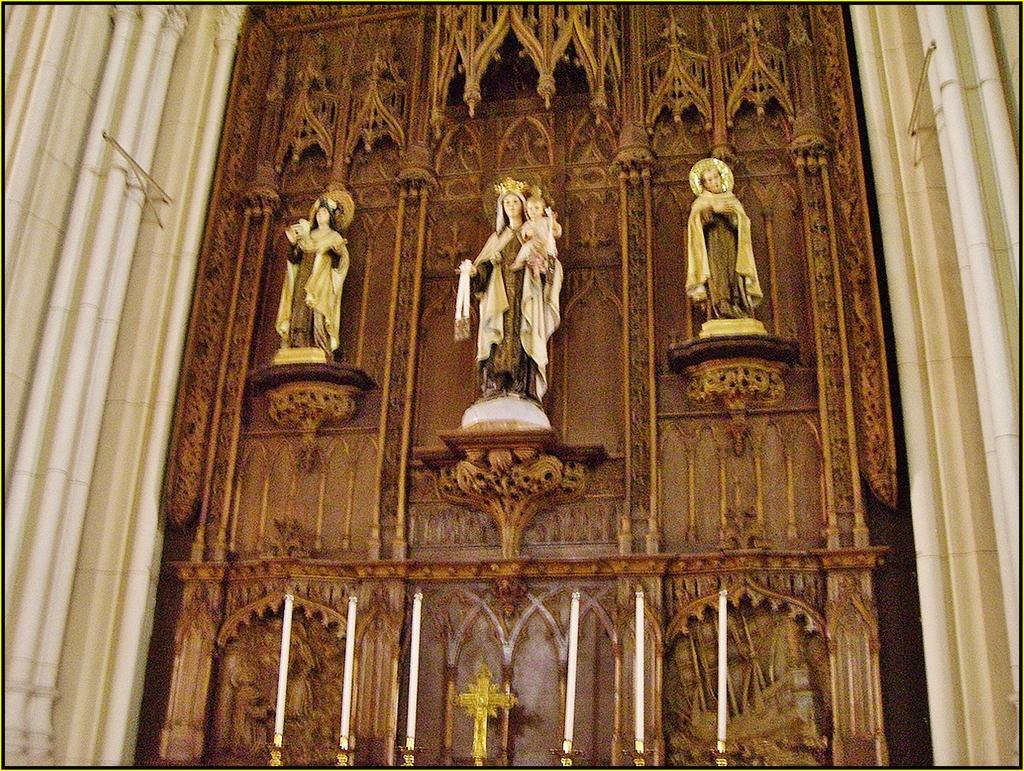What can be seen on the wall in the image? There are statues on the wall in the image. What architectural features are present in the image? There are pillars in the image. What items are related to lighting in the image? There are candles and candle holders in the image. What type of jam is being served on the plate in the image? There is no plate or jam present in the image. How much sugar is being used to sweeten the candles in the image? There is no sugar involved in the candles in the image; they are simply burning for light. 